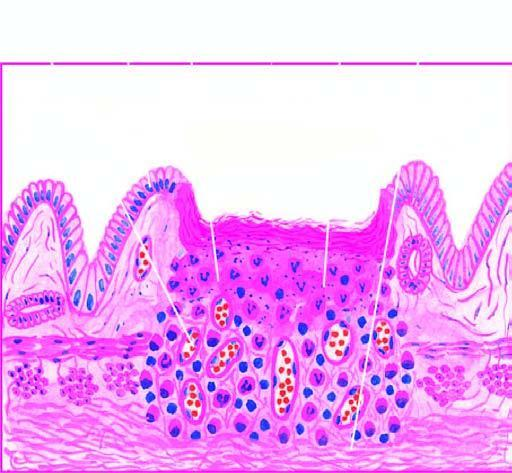re strands illustrated in the diagram?
Answer the question using a single word or phrase. No 